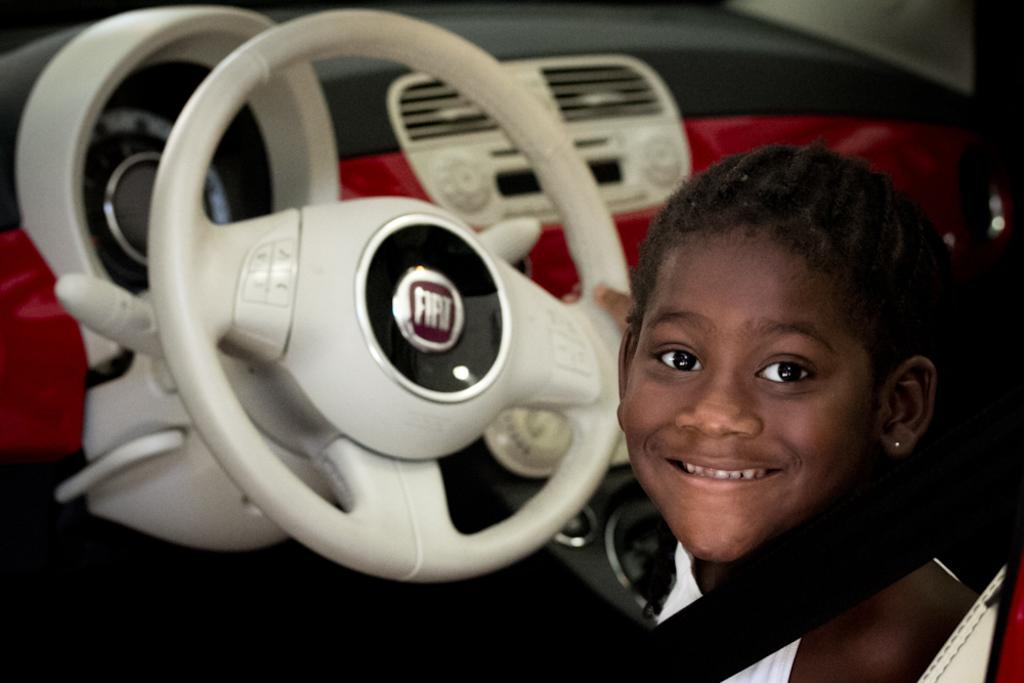What is the girl doing inside the car? The girl is sitting inside the car and touching the steering wheel. How is the girl positioned in the car? The girl is wearing a seatbelt while sitting inside the car. What is the girl's facial expression in the image? The girl is smiling in the image. What feature of the car is visible in the image? There is an air conditioning (AC) inside the car, and a meter is also visible. How many boys are waving the flag outside the car in the image? There are no boys or flags present in the image. What type of cherry is being used as a decoration inside the car? There is no cherry present in the image. 